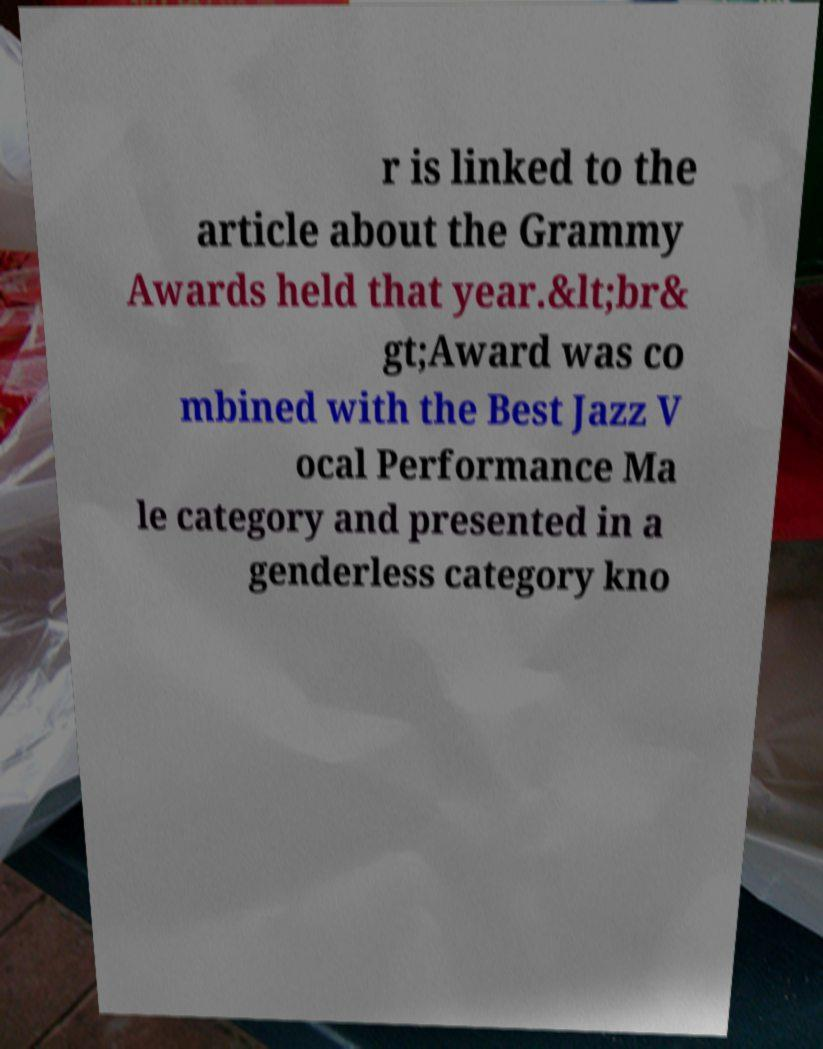There's text embedded in this image that I need extracted. Can you transcribe it verbatim? r is linked to the article about the Grammy Awards held that year.&lt;br& gt;Award was co mbined with the Best Jazz V ocal Performance Ma le category and presented in a genderless category kno 